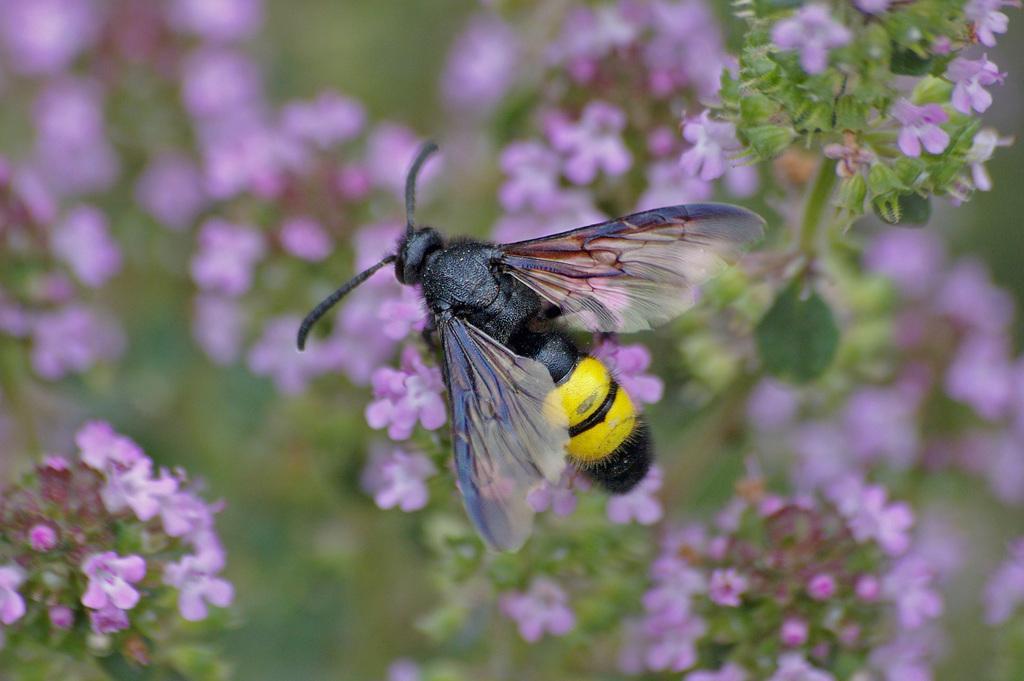Could you give a brief overview of what you see in this image? In this image we can see a insect on bunch of flowers. In the background we can see flowers on plants. 